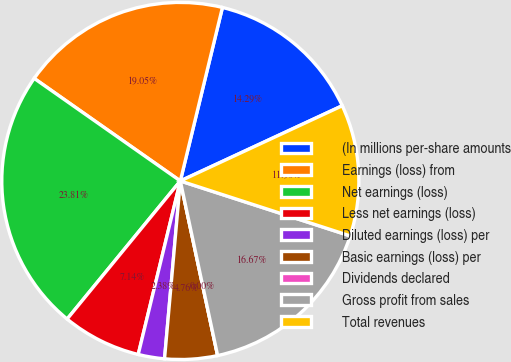<chart> <loc_0><loc_0><loc_500><loc_500><pie_chart><fcel>(In millions per-share amounts<fcel>Earnings (loss) from<fcel>Net earnings (loss)<fcel>Less net earnings (loss)<fcel>Diluted earnings (loss) per<fcel>Basic earnings (loss) per<fcel>Dividends declared<fcel>Gross profit from sales<fcel>Total revenues<nl><fcel>14.29%<fcel>19.05%<fcel>23.81%<fcel>7.14%<fcel>2.38%<fcel>4.76%<fcel>0.0%<fcel>16.67%<fcel>11.9%<nl></chart> 